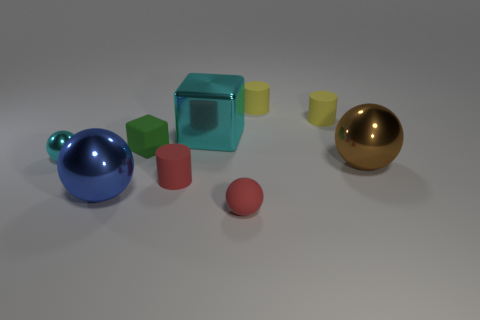Subtract all purple balls. Subtract all purple cylinders. How many balls are left? 4 Subtract all cylinders. How many objects are left? 6 Add 7 small cyan metal objects. How many small cyan metal objects exist? 8 Subtract 0 purple blocks. How many objects are left? 9 Subtract all metal balls. Subtract all tiny red matte cylinders. How many objects are left? 5 Add 9 large cyan objects. How many large cyan objects are left? 10 